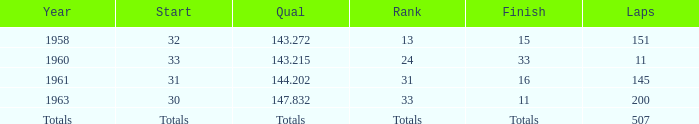In what year did the 31st rank take place? 1961.0. 